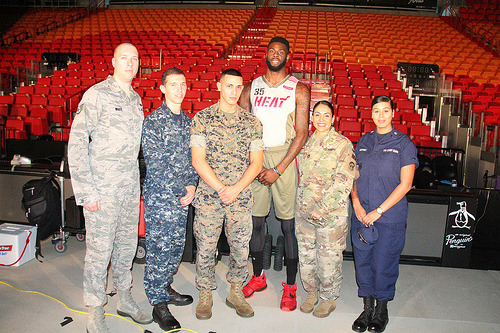<image>
Is there a woman to the left of the man? No. The woman is not to the left of the man. From this viewpoint, they have a different horizontal relationship. 